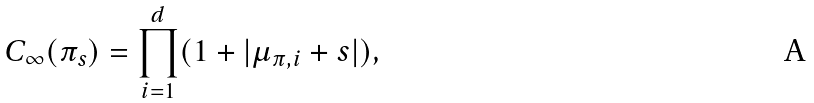<formula> <loc_0><loc_0><loc_500><loc_500>C _ { \infty } ( \pi _ { s } ) = \prod _ { i = 1 } ^ { d } ( 1 + | \mu _ { \pi , i } + s | ) ,</formula> 